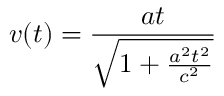Convert formula to latex. <formula><loc_0><loc_0><loc_500><loc_500>v ( t ) = { \frac { a t } { \sqrt { 1 + { \frac { a ^ { 2 } t ^ { 2 } } { c ^ { 2 } } } } } }</formula> 